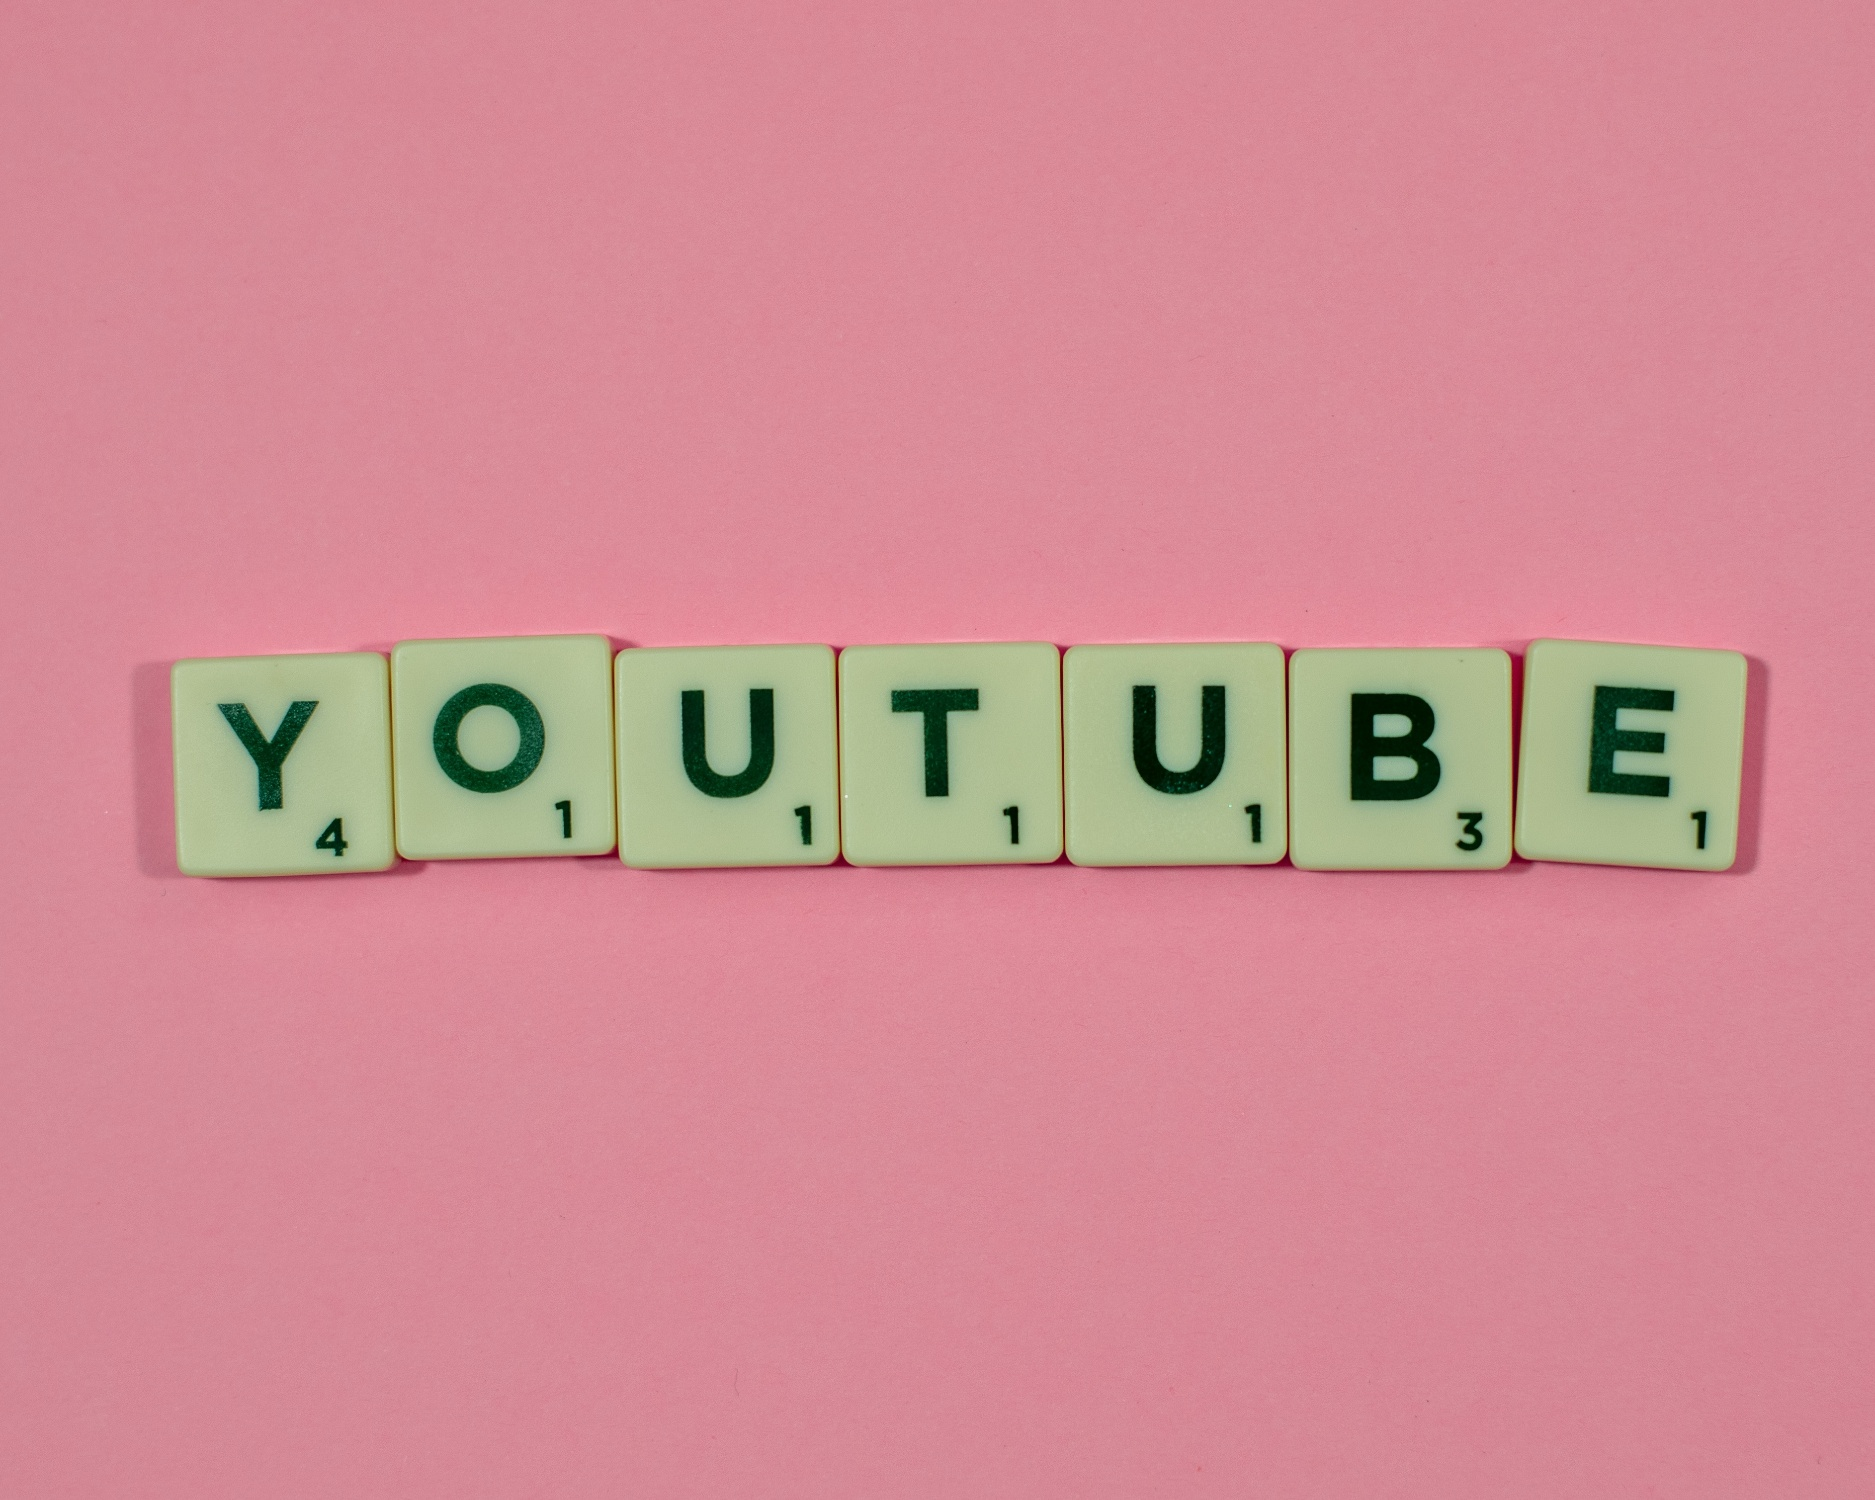Imagine the pink background as a portal. Where does it lead? The pink background acts as a magical portal leading to a vibrant, fantastical realm where creativity reigns supreme. As one steps through the portal, they are greeted by a sprawling landscape filled with floating islands, each dedicated to a different form of artistic expression. On one island, giant paintbrushes sweep across enormous canvases creating dynamic art pieces. Another island vibrates with the sound of music, where melodies take physical form and dance in the air. There’s an island where stories come to life, with characters from books and tales wandering and interacting. Each step in this world reveals another layer of imagination, where the boundaries of creativity are limitless, encouraging explorers to add their unique touch to this ever-evolving artistic universe. 